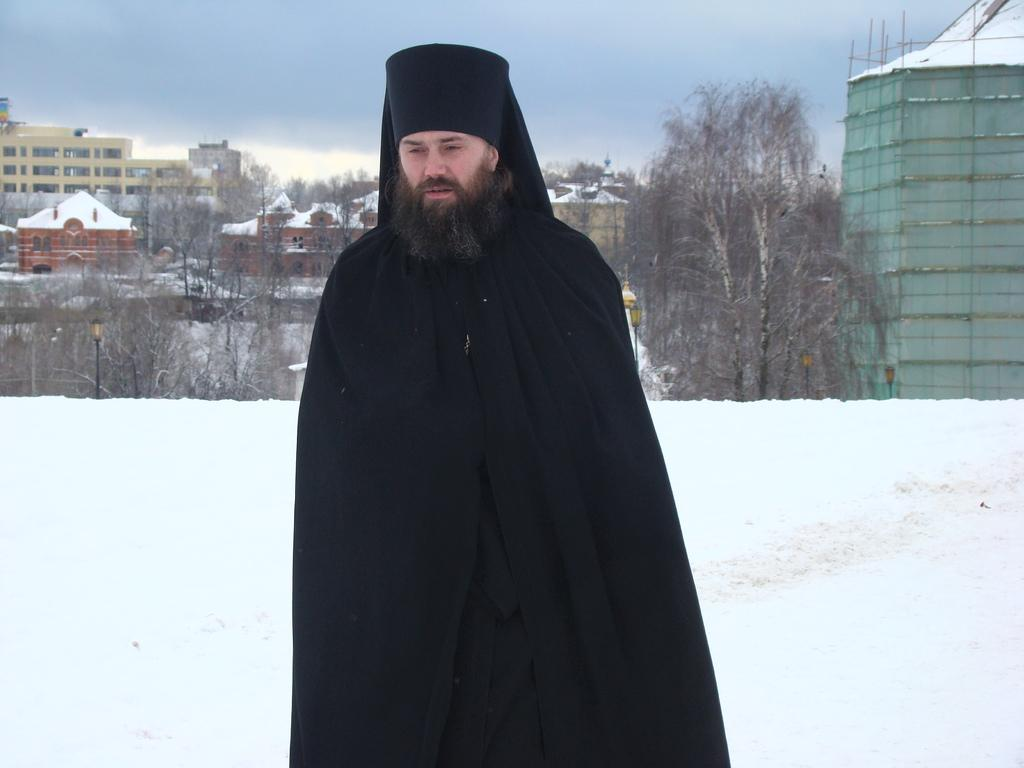What is the main subject in the center of the image? There is a person in the center of the image. What is the person wearing in the image? The person is wearing clothes and a cap. What can be seen in the background of the image? There are trees, buildings, and lights visible in the background of the image. What is the weather like in the image? The presence of snow suggests that it is likely cold and possibly snowing. What is visible at the top of the image? The sky is visible at the top of the image. How many spiders are crawling on the person's clothes in the image? There are no spiders visible on the person's clothes in the image. What type of pencil is the person holding in the image? There is no pencil present in the image. 